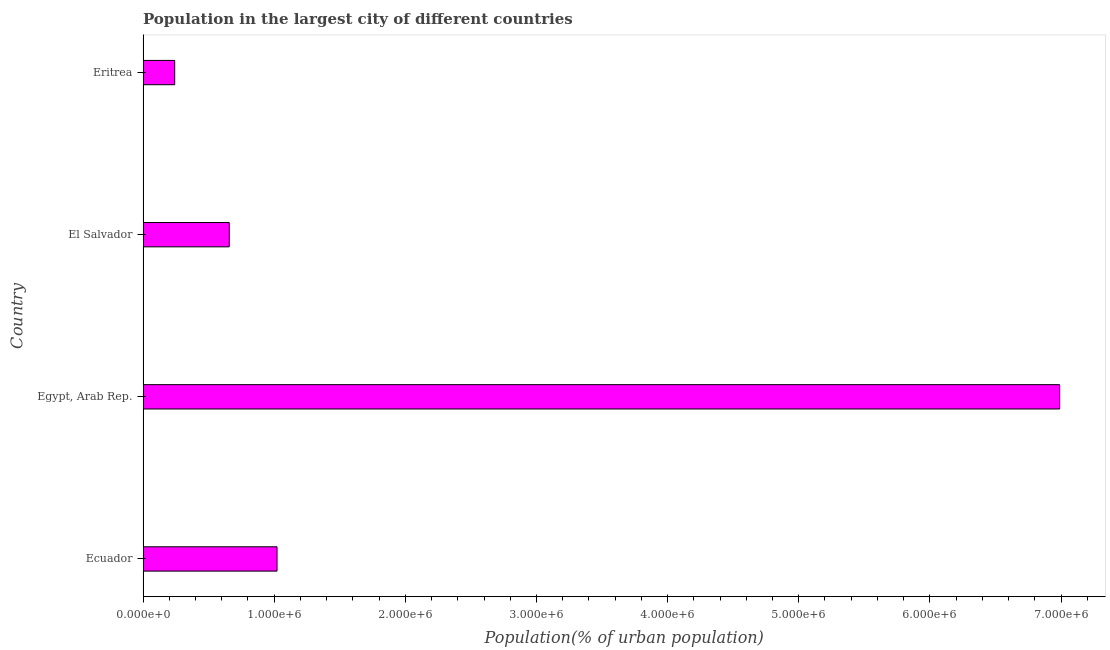What is the title of the graph?
Your answer should be compact. Population in the largest city of different countries. What is the label or title of the X-axis?
Provide a succinct answer. Population(% of urban population). What is the population in largest city in Egypt, Arab Rep.?
Provide a succinct answer. 6.99e+06. Across all countries, what is the maximum population in largest city?
Your response must be concise. 6.99e+06. Across all countries, what is the minimum population in largest city?
Give a very brief answer. 2.41e+05. In which country was the population in largest city maximum?
Make the answer very short. Egypt, Arab Rep. In which country was the population in largest city minimum?
Provide a short and direct response. Eritrea. What is the sum of the population in largest city?
Offer a terse response. 8.91e+06. What is the difference between the population in largest city in El Salvador and Eritrea?
Offer a very short reply. 4.16e+05. What is the average population in largest city per country?
Your answer should be very brief. 2.23e+06. What is the median population in largest city?
Make the answer very short. 8.39e+05. What is the ratio of the population in largest city in Egypt, Arab Rep. to that in El Salvador?
Make the answer very short. 10.64. What is the difference between the highest and the second highest population in largest city?
Ensure brevity in your answer.  5.97e+06. Is the sum of the population in largest city in Ecuador and Egypt, Arab Rep. greater than the maximum population in largest city across all countries?
Make the answer very short. Yes. What is the difference between the highest and the lowest population in largest city?
Ensure brevity in your answer.  6.75e+06. In how many countries, is the population in largest city greater than the average population in largest city taken over all countries?
Your answer should be compact. 1. How many bars are there?
Make the answer very short. 4. Are all the bars in the graph horizontal?
Ensure brevity in your answer.  Yes. How many countries are there in the graph?
Provide a short and direct response. 4. Are the values on the major ticks of X-axis written in scientific E-notation?
Provide a short and direct response. Yes. What is the Population(% of urban population) of Ecuador?
Give a very brief answer. 1.02e+06. What is the Population(% of urban population) in Egypt, Arab Rep.?
Provide a short and direct response. 6.99e+06. What is the Population(% of urban population) of El Salvador?
Offer a very short reply. 6.57e+05. What is the Population(% of urban population) in Eritrea?
Your response must be concise. 2.41e+05. What is the difference between the Population(% of urban population) in Ecuador and Egypt, Arab Rep.?
Your answer should be compact. -5.97e+06. What is the difference between the Population(% of urban population) in Ecuador and El Salvador?
Your response must be concise. 3.64e+05. What is the difference between the Population(% of urban population) in Ecuador and Eritrea?
Make the answer very short. 7.80e+05. What is the difference between the Population(% of urban population) in Egypt, Arab Rep. and El Salvador?
Provide a short and direct response. 6.33e+06. What is the difference between the Population(% of urban population) in Egypt, Arab Rep. and Eritrea?
Make the answer very short. 6.75e+06. What is the difference between the Population(% of urban population) in El Salvador and Eritrea?
Make the answer very short. 4.16e+05. What is the ratio of the Population(% of urban population) in Ecuador to that in Egypt, Arab Rep.?
Your answer should be compact. 0.15. What is the ratio of the Population(% of urban population) in Ecuador to that in El Salvador?
Your response must be concise. 1.55. What is the ratio of the Population(% of urban population) in Ecuador to that in Eritrea?
Make the answer very short. 4.24. What is the ratio of the Population(% of urban population) in Egypt, Arab Rep. to that in El Salvador?
Provide a succinct answer. 10.64. What is the ratio of the Population(% of urban population) in Egypt, Arab Rep. to that in Eritrea?
Make the answer very short. 28.97. What is the ratio of the Population(% of urban population) in El Salvador to that in Eritrea?
Your answer should be very brief. 2.72. 